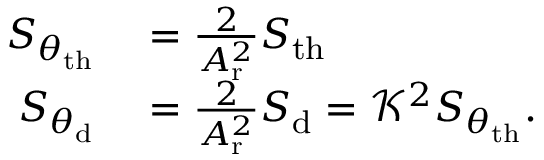Convert formula to latex. <formula><loc_0><loc_0><loc_500><loc_500>\begin{array} { r l } { S _ { \theta _ { t h } } } & = \frac { 2 } { A _ { r } ^ { 2 } } S _ { t h } } \\ { S _ { \theta _ { d } } } & = \frac { 2 } { A _ { r } ^ { 2 } } S _ { d } = \mathcal { K } ^ { 2 } S _ { \theta _ { t h } } . } \end{array}</formula> 